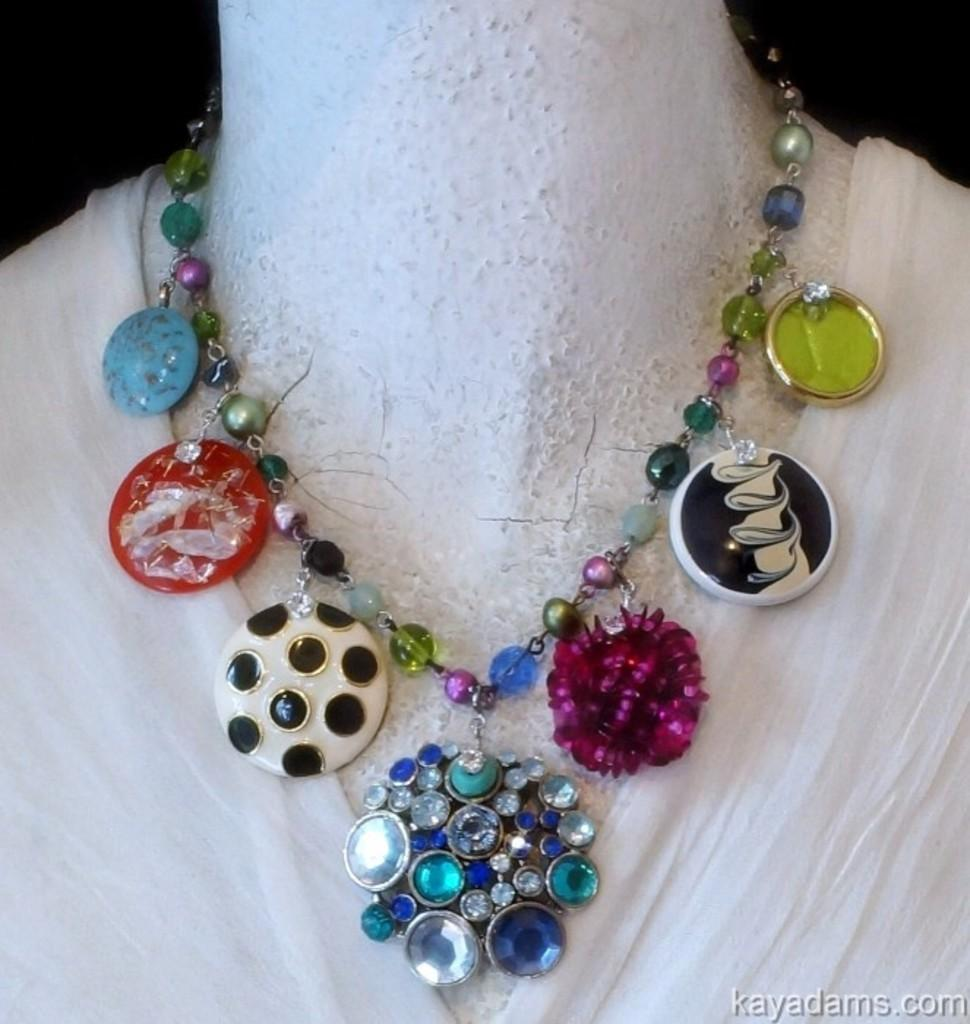What is placed on the mannequin in the image? There is a necklace on a mannequin in the image. Can you describe any additional features of the image? There is a watermark in the bottom right-hand side of the image. What type of quilt is draped over the mannequin in the image? There is no quilt present in the image; it only features a necklace on a mannequin and a watermark. 